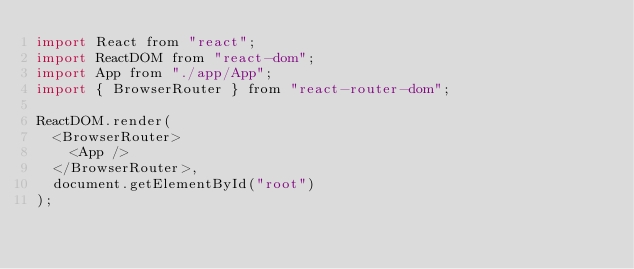<code> <loc_0><loc_0><loc_500><loc_500><_JavaScript_>import React from "react";
import ReactDOM from "react-dom";
import App from "./app/App";
import { BrowserRouter } from "react-router-dom";

ReactDOM.render(
  <BrowserRouter>
    <App />
  </BrowserRouter>,
  document.getElementById("root")
);
</code> 